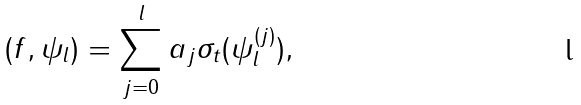Convert formula to latex. <formula><loc_0><loc_0><loc_500><loc_500>( f , \psi _ { l } ) = \sum _ { j = 0 } ^ { l } a _ { j } \sigma _ { t } ( \psi ^ { ( j ) } _ { l } ) ,</formula> 